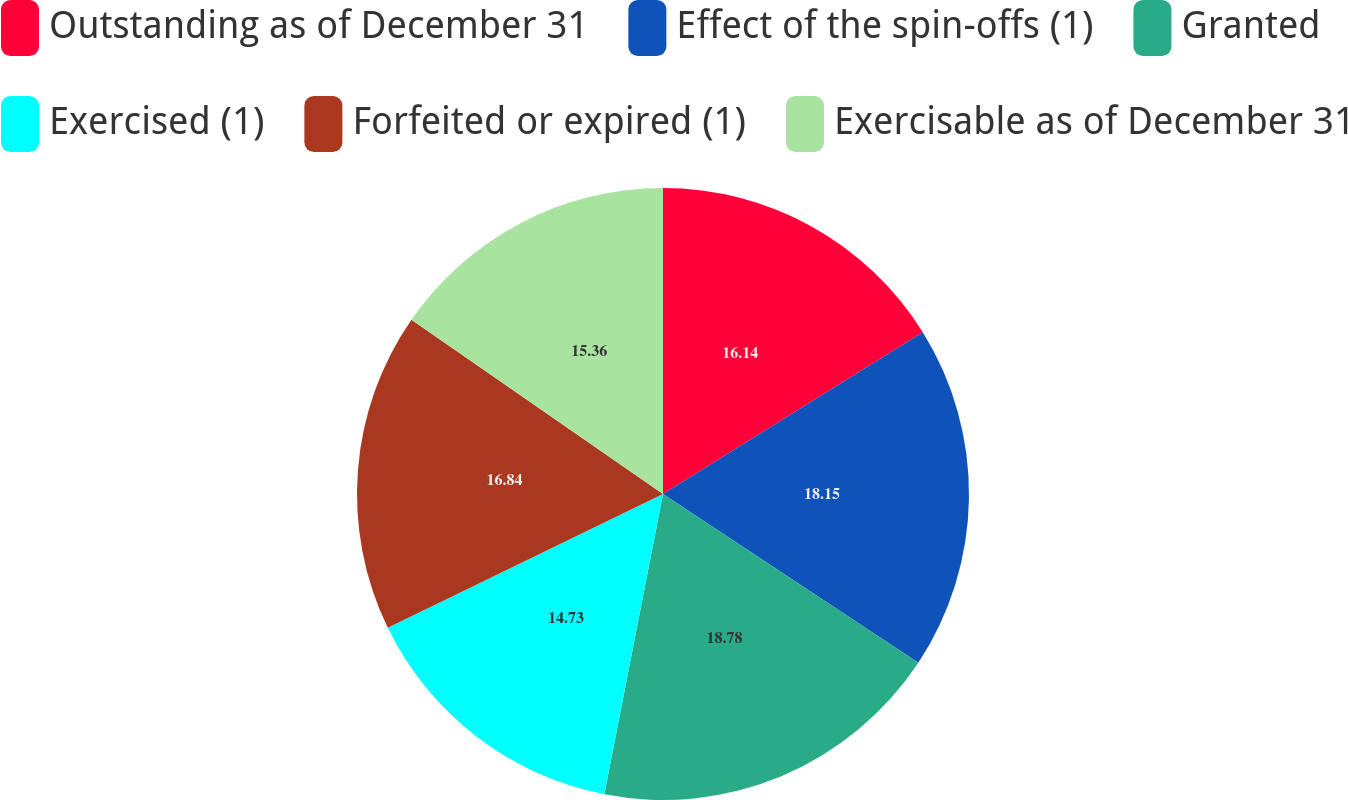<chart> <loc_0><loc_0><loc_500><loc_500><pie_chart><fcel>Outstanding as of December 31<fcel>Effect of the spin-offs (1)<fcel>Granted<fcel>Exercised (1)<fcel>Forfeited or expired (1)<fcel>Exercisable as of December 31<nl><fcel>16.14%<fcel>18.15%<fcel>18.78%<fcel>14.73%<fcel>16.84%<fcel>15.36%<nl></chart> 